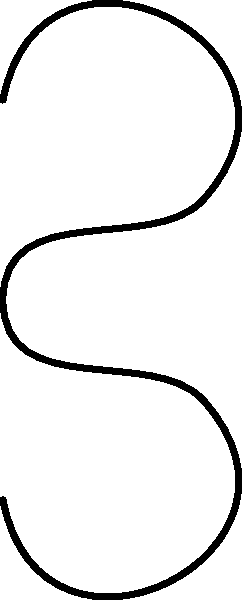According to the biomechanical principles of spinal alignment, which of the three postures shown in the diagram is most likely to reduce the risk of chronic back pain and improve overall spinal health? Explain the key differences between the postures and their potential impact on spinal loading and muscle strain. To answer this question, let's analyze each posture and its biomechanical implications:

1. Neutral spine (left):
   - This represents the natural curvature of the spine.
   - It serves as a reference point for comparison.

2. Proper posture (middle, green):
   - Maintains the natural curves of the spine, including cervical lordosis, thoracic kyphosis, and lumbar lordosis.
   - Distributes body weight evenly along the spine.
   - Minimizes stress on spinal ligaments, muscles, and intervertebral discs.
   - Reduces the risk of muscle fatigue and strain.

3. Improper posture (right, red):
   - Shows exaggerated curves, particularly in the lumbar and cervical regions.
   - Increases stress on certain parts of the spine, leading to uneven loading.
   - Can cause muscle imbalances and strain.
   - May lead to accelerated wear and tear on spinal structures.

Key differences and their impacts:

a. Spinal curvature:
   - Proper posture maintains natural curves, while improper posture exaggerates them.
   - Natural curves act as shock absorbers, distributing forces evenly.

b. Muscle activation:
   - Proper posture requires less muscle activity to maintain, reducing fatigue.
   - Improper posture often leads to overactivation of certain muscle groups and underuse of others.

c. Joint stress:
   - Proper alignment minimizes stress on facet joints and intervertebral discs.
   - Improper posture can increase pressure on these structures, potentially leading to degeneration over time.

d. Energy expenditure:
   - Maintaining proper posture is more energy-efficient in the long term.
   - Improper posture requires more energy to counteract gravitational forces.

e. Long-term health implications:
   - Proper posture reduces the risk of chronic pain, muscle imbalances, and spinal degeneration.
   - Improper posture increases the likelihood of developing these issues over time.

Therefore, the proper posture (middle, green) is most likely to reduce the risk of chronic back pain and improve overall spinal health. It optimizes biomechanical loading, minimizes unnecessary muscle strain, and promotes long-term spinal health.
Answer: Proper posture (middle, green) - maintains natural spinal curves, optimizes load distribution, and minimizes muscle strain. 